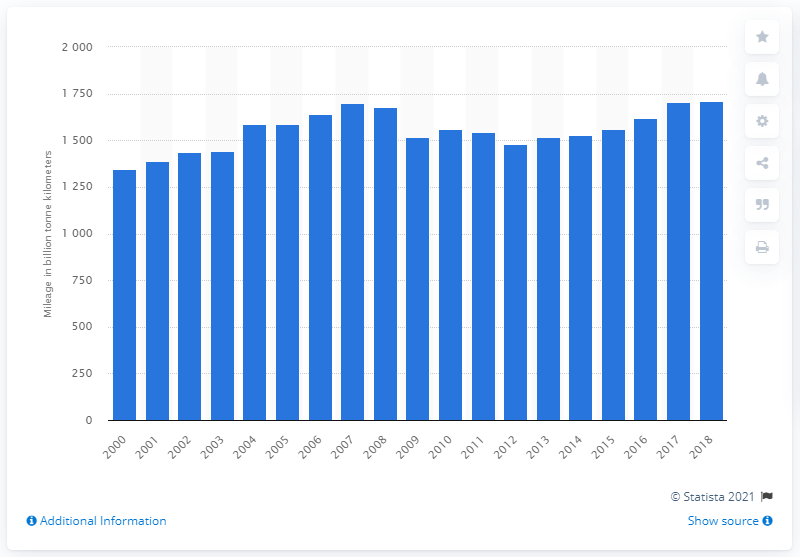Mention a couple of crucial points in this snapshot. In 2018, freight traveled a total of 1,708.9 kilometers on European roads. 